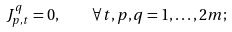<formula> <loc_0><loc_0><loc_500><loc_500>J _ { p , t } ^ { q } = 0 , \quad \forall t , p , q = 1 , \dots , 2 m ;</formula> 